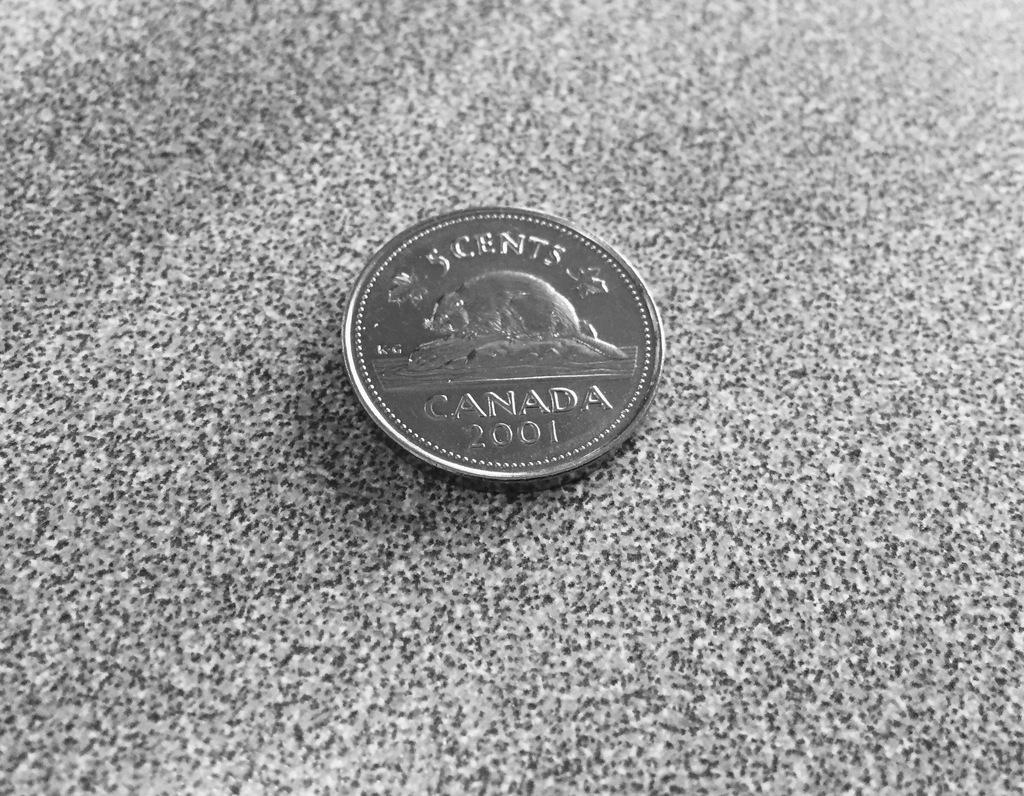<image>
Give a short and clear explanation of the subsequent image. a Canadian coin with a beaver worth 5 cents 